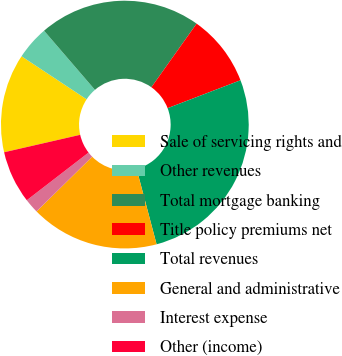<chart> <loc_0><loc_0><loc_500><loc_500><pie_chart><fcel>Sale of servicing rights and<fcel>Other revenues<fcel>Total mortgage banking<fcel>Title policy premiums net<fcel>Total revenues<fcel>General and administrative<fcel>Interest expense<fcel>Other (income)<nl><fcel>12.89%<fcel>4.39%<fcel>21.15%<fcel>9.34%<fcel>26.7%<fcel>16.76%<fcel>1.91%<fcel>6.87%<nl></chart> 